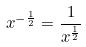Convert formula to latex. <formula><loc_0><loc_0><loc_500><loc_500>x ^ { - \frac { 1 } { 2 } } = \frac { 1 } { x ^ { \frac { 1 } { 2 } } }</formula> 